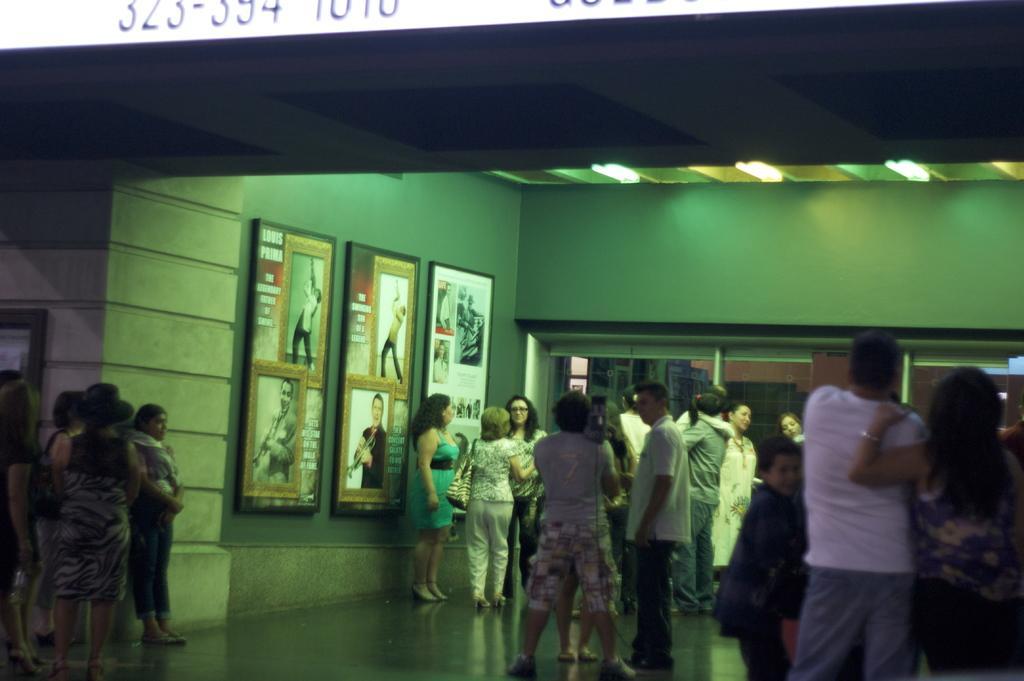Could you give a brief overview of what you see in this image? In this picture there are people and we can see floor, boards on the wall and lights. At the top of the image we can see numbers. 